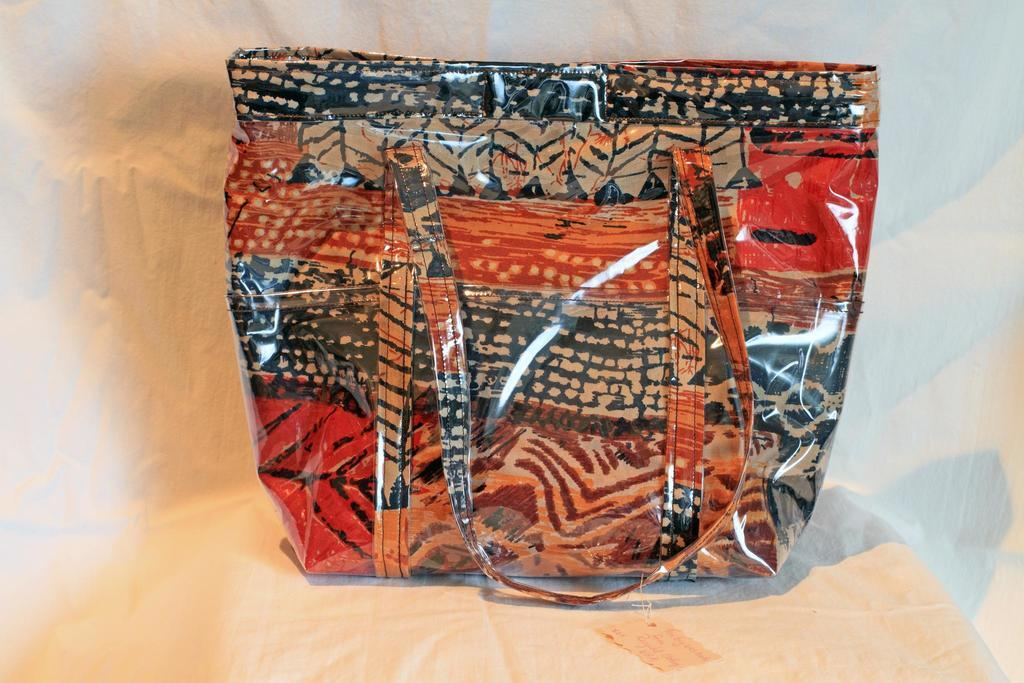What object can be seen in the image? There is a bag in the image. What colors are present on the bag? The bag has red, black, and brown colors. What type of marble is visible on the roof in the image? There is no marble or roof present in the image; it only features a bag with red, black, and brown colors. 